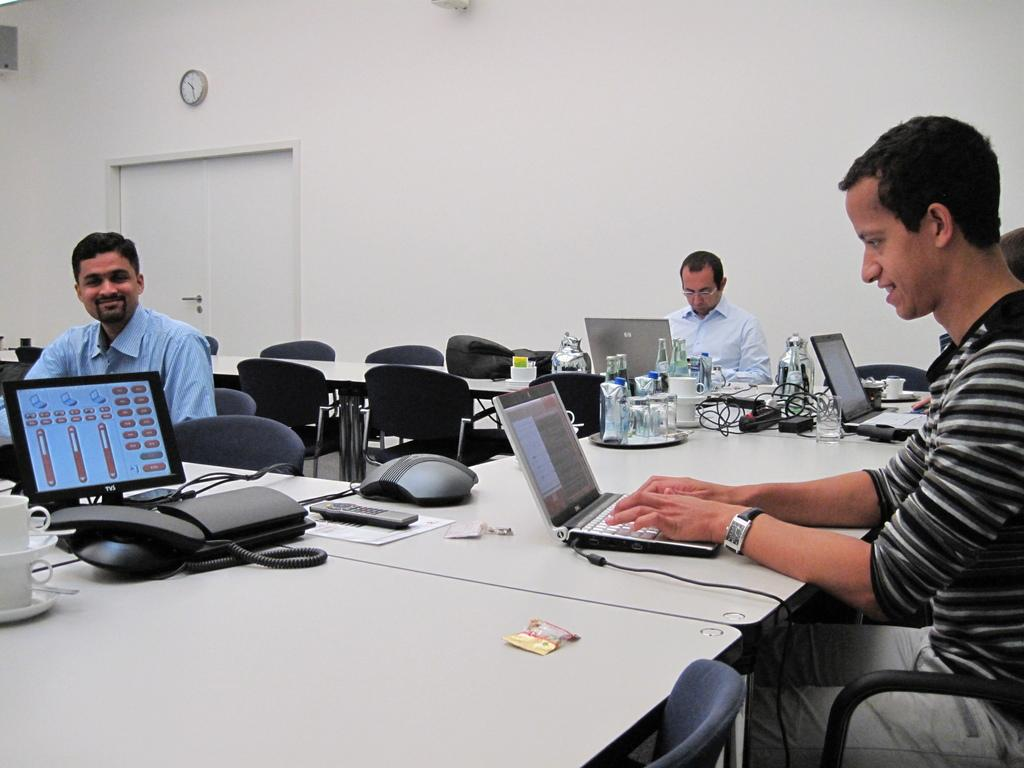What type of furniture is present in the image? There are chairs and a table in the image. What electronic devices can be seen in the image? There is a laptop and a phone in the image. What type of beverage containers are in the image? There are cups in the image. Are there any people present in the image? Yes, there are people in the image. Can you describe any other objects in the image besides the ones mentioned? There are other objects in the image, but their specific details are not provided. Where is the watch located in the image? The watch is in the background of the image. What is the chance of the crate being used as a seat in the image? There is no crate present in the image, so it cannot be used as a seat. Who is the writer in the image? There is no mention of a writer in the image, so we cannot identify one. 